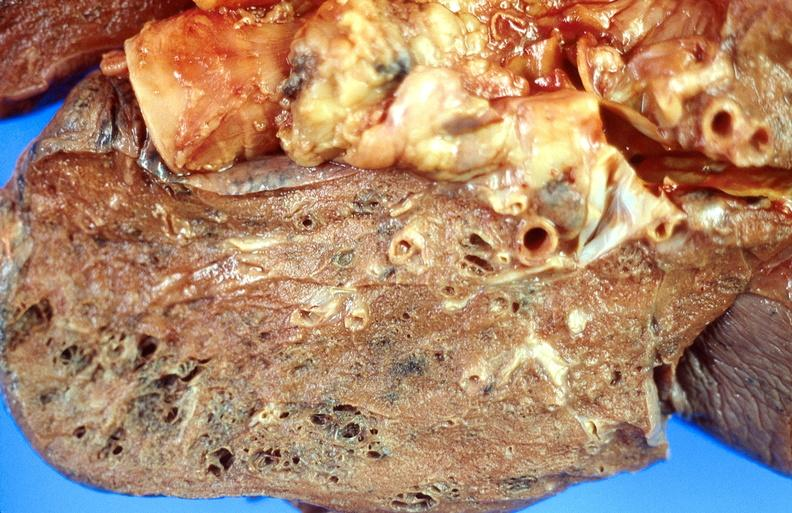what does this image show?
Answer the question using a single word or phrase. Cryptococcal pneumonia 